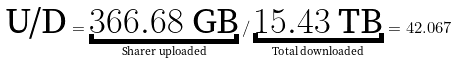Convert formula to latex. <formula><loc_0><loc_0><loc_500><loc_500>\text {U/D} = \underbracket { 3 6 6 . 6 8 \text { GB} } _ { \text {Sharer uploaded} } / \underbracket { 1 5 . 4 3 \text { TB} } _ { \text {Total downloaded} } = 4 2 . 0 6 7</formula> 